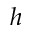Convert formula to latex. <formula><loc_0><loc_0><loc_500><loc_500>h</formula> 